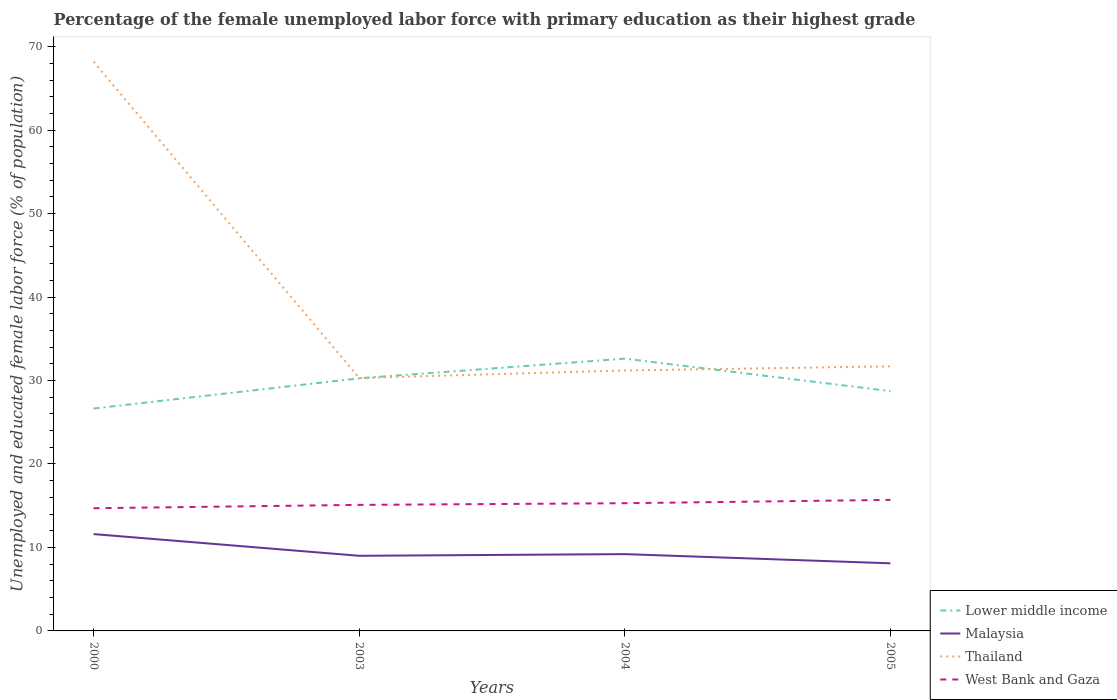Across all years, what is the maximum percentage of the unemployed female labor force with primary education in Lower middle income?
Provide a succinct answer. 26.65. In which year was the percentage of the unemployed female labor force with primary education in Lower middle income maximum?
Your answer should be compact. 2000. What is the total percentage of the unemployed female labor force with primary education in West Bank and Gaza in the graph?
Make the answer very short. -0.6. What is the difference between the highest and the second highest percentage of the unemployed female labor force with primary education in West Bank and Gaza?
Give a very brief answer. 1. What is the difference between the highest and the lowest percentage of the unemployed female labor force with primary education in West Bank and Gaza?
Your answer should be very brief. 2. Is the percentage of the unemployed female labor force with primary education in Malaysia strictly greater than the percentage of the unemployed female labor force with primary education in Thailand over the years?
Your response must be concise. Yes. How many years are there in the graph?
Offer a terse response. 4. Does the graph contain grids?
Offer a very short reply. No. Where does the legend appear in the graph?
Offer a very short reply. Bottom right. How are the legend labels stacked?
Provide a succinct answer. Vertical. What is the title of the graph?
Ensure brevity in your answer.  Percentage of the female unemployed labor force with primary education as their highest grade. What is the label or title of the X-axis?
Give a very brief answer. Years. What is the label or title of the Y-axis?
Ensure brevity in your answer.  Unemployed and educated female labor force (% of population). What is the Unemployed and educated female labor force (% of population) of Lower middle income in 2000?
Give a very brief answer. 26.65. What is the Unemployed and educated female labor force (% of population) in Malaysia in 2000?
Give a very brief answer. 11.6. What is the Unemployed and educated female labor force (% of population) in Thailand in 2000?
Offer a very short reply. 68.2. What is the Unemployed and educated female labor force (% of population) in West Bank and Gaza in 2000?
Ensure brevity in your answer.  14.7. What is the Unemployed and educated female labor force (% of population) of Lower middle income in 2003?
Your answer should be very brief. 30.26. What is the Unemployed and educated female labor force (% of population) in Malaysia in 2003?
Provide a succinct answer. 9. What is the Unemployed and educated female labor force (% of population) in Thailand in 2003?
Offer a terse response. 30.3. What is the Unemployed and educated female labor force (% of population) of West Bank and Gaza in 2003?
Offer a terse response. 15.1. What is the Unemployed and educated female labor force (% of population) of Lower middle income in 2004?
Provide a short and direct response. 32.62. What is the Unemployed and educated female labor force (% of population) in Malaysia in 2004?
Provide a short and direct response. 9.2. What is the Unemployed and educated female labor force (% of population) in Thailand in 2004?
Offer a very short reply. 31.2. What is the Unemployed and educated female labor force (% of population) of West Bank and Gaza in 2004?
Ensure brevity in your answer.  15.3. What is the Unemployed and educated female labor force (% of population) of Lower middle income in 2005?
Ensure brevity in your answer.  28.73. What is the Unemployed and educated female labor force (% of population) of Malaysia in 2005?
Your answer should be compact. 8.1. What is the Unemployed and educated female labor force (% of population) in Thailand in 2005?
Provide a succinct answer. 31.7. What is the Unemployed and educated female labor force (% of population) in West Bank and Gaza in 2005?
Your answer should be very brief. 15.7. Across all years, what is the maximum Unemployed and educated female labor force (% of population) of Lower middle income?
Provide a short and direct response. 32.62. Across all years, what is the maximum Unemployed and educated female labor force (% of population) of Malaysia?
Offer a terse response. 11.6. Across all years, what is the maximum Unemployed and educated female labor force (% of population) of Thailand?
Offer a terse response. 68.2. Across all years, what is the maximum Unemployed and educated female labor force (% of population) in West Bank and Gaza?
Ensure brevity in your answer.  15.7. Across all years, what is the minimum Unemployed and educated female labor force (% of population) in Lower middle income?
Your response must be concise. 26.65. Across all years, what is the minimum Unemployed and educated female labor force (% of population) of Malaysia?
Offer a very short reply. 8.1. Across all years, what is the minimum Unemployed and educated female labor force (% of population) of Thailand?
Your response must be concise. 30.3. Across all years, what is the minimum Unemployed and educated female labor force (% of population) of West Bank and Gaza?
Offer a very short reply. 14.7. What is the total Unemployed and educated female labor force (% of population) in Lower middle income in the graph?
Your response must be concise. 118.26. What is the total Unemployed and educated female labor force (% of population) of Malaysia in the graph?
Give a very brief answer. 37.9. What is the total Unemployed and educated female labor force (% of population) of Thailand in the graph?
Make the answer very short. 161.4. What is the total Unemployed and educated female labor force (% of population) of West Bank and Gaza in the graph?
Keep it short and to the point. 60.8. What is the difference between the Unemployed and educated female labor force (% of population) of Lower middle income in 2000 and that in 2003?
Your answer should be very brief. -3.62. What is the difference between the Unemployed and educated female labor force (% of population) in Thailand in 2000 and that in 2003?
Your answer should be very brief. 37.9. What is the difference between the Unemployed and educated female labor force (% of population) of West Bank and Gaza in 2000 and that in 2003?
Give a very brief answer. -0.4. What is the difference between the Unemployed and educated female labor force (% of population) of Lower middle income in 2000 and that in 2004?
Make the answer very short. -5.98. What is the difference between the Unemployed and educated female labor force (% of population) of Malaysia in 2000 and that in 2004?
Your answer should be very brief. 2.4. What is the difference between the Unemployed and educated female labor force (% of population) in Lower middle income in 2000 and that in 2005?
Your response must be concise. -2.09. What is the difference between the Unemployed and educated female labor force (% of population) in Malaysia in 2000 and that in 2005?
Your answer should be very brief. 3.5. What is the difference between the Unemployed and educated female labor force (% of population) of Thailand in 2000 and that in 2005?
Offer a terse response. 36.5. What is the difference between the Unemployed and educated female labor force (% of population) in West Bank and Gaza in 2000 and that in 2005?
Offer a very short reply. -1. What is the difference between the Unemployed and educated female labor force (% of population) in Lower middle income in 2003 and that in 2004?
Offer a very short reply. -2.36. What is the difference between the Unemployed and educated female labor force (% of population) of Malaysia in 2003 and that in 2004?
Your answer should be compact. -0.2. What is the difference between the Unemployed and educated female labor force (% of population) of Lower middle income in 2003 and that in 2005?
Your answer should be compact. 1.53. What is the difference between the Unemployed and educated female labor force (% of population) in Thailand in 2003 and that in 2005?
Your answer should be compact. -1.4. What is the difference between the Unemployed and educated female labor force (% of population) in Lower middle income in 2004 and that in 2005?
Provide a short and direct response. 3.89. What is the difference between the Unemployed and educated female labor force (% of population) of West Bank and Gaza in 2004 and that in 2005?
Give a very brief answer. -0.4. What is the difference between the Unemployed and educated female labor force (% of population) of Lower middle income in 2000 and the Unemployed and educated female labor force (% of population) of Malaysia in 2003?
Keep it short and to the point. 17.65. What is the difference between the Unemployed and educated female labor force (% of population) in Lower middle income in 2000 and the Unemployed and educated female labor force (% of population) in Thailand in 2003?
Ensure brevity in your answer.  -3.65. What is the difference between the Unemployed and educated female labor force (% of population) of Lower middle income in 2000 and the Unemployed and educated female labor force (% of population) of West Bank and Gaza in 2003?
Provide a short and direct response. 11.55. What is the difference between the Unemployed and educated female labor force (% of population) of Malaysia in 2000 and the Unemployed and educated female labor force (% of population) of Thailand in 2003?
Your answer should be very brief. -18.7. What is the difference between the Unemployed and educated female labor force (% of population) of Thailand in 2000 and the Unemployed and educated female labor force (% of population) of West Bank and Gaza in 2003?
Make the answer very short. 53.1. What is the difference between the Unemployed and educated female labor force (% of population) in Lower middle income in 2000 and the Unemployed and educated female labor force (% of population) in Malaysia in 2004?
Offer a terse response. 17.45. What is the difference between the Unemployed and educated female labor force (% of population) in Lower middle income in 2000 and the Unemployed and educated female labor force (% of population) in Thailand in 2004?
Ensure brevity in your answer.  -4.55. What is the difference between the Unemployed and educated female labor force (% of population) in Lower middle income in 2000 and the Unemployed and educated female labor force (% of population) in West Bank and Gaza in 2004?
Ensure brevity in your answer.  11.35. What is the difference between the Unemployed and educated female labor force (% of population) of Malaysia in 2000 and the Unemployed and educated female labor force (% of population) of Thailand in 2004?
Offer a very short reply. -19.6. What is the difference between the Unemployed and educated female labor force (% of population) of Thailand in 2000 and the Unemployed and educated female labor force (% of population) of West Bank and Gaza in 2004?
Give a very brief answer. 52.9. What is the difference between the Unemployed and educated female labor force (% of population) of Lower middle income in 2000 and the Unemployed and educated female labor force (% of population) of Malaysia in 2005?
Your answer should be compact. 18.55. What is the difference between the Unemployed and educated female labor force (% of population) of Lower middle income in 2000 and the Unemployed and educated female labor force (% of population) of Thailand in 2005?
Give a very brief answer. -5.05. What is the difference between the Unemployed and educated female labor force (% of population) in Lower middle income in 2000 and the Unemployed and educated female labor force (% of population) in West Bank and Gaza in 2005?
Ensure brevity in your answer.  10.95. What is the difference between the Unemployed and educated female labor force (% of population) in Malaysia in 2000 and the Unemployed and educated female labor force (% of population) in Thailand in 2005?
Offer a terse response. -20.1. What is the difference between the Unemployed and educated female labor force (% of population) in Malaysia in 2000 and the Unemployed and educated female labor force (% of population) in West Bank and Gaza in 2005?
Give a very brief answer. -4.1. What is the difference between the Unemployed and educated female labor force (% of population) of Thailand in 2000 and the Unemployed and educated female labor force (% of population) of West Bank and Gaza in 2005?
Provide a succinct answer. 52.5. What is the difference between the Unemployed and educated female labor force (% of population) in Lower middle income in 2003 and the Unemployed and educated female labor force (% of population) in Malaysia in 2004?
Your response must be concise. 21.06. What is the difference between the Unemployed and educated female labor force (% of population) in Lower middle income in 2003 and the Unemployed and educated female labor force (% of population) in Thailand in 2004?
Keep it short and to the point. -0.94. What is the difference between the Unemployed and educated female labor force (% of population) in Lower middle income in 2003 and the Unemployed and educated female labor force (% of population) in West Bank and Gaza in 2004?
Offer a terse response. 14.96. What is the difference between the Unemployed and educated female labor force (% of population) of Malaysia in 2003 and the Unemployed and educated female labor force (% of population) of Thailand in 2004?
Provide a short and direct response. -22.2. What is the difference between the Unemployed and educated female labor force (% of population) of Lower middle income in 2003 and the Unemployed and educated female labor force (% of population) of Malaysia in 2005?
Offer a terse response. 22.16. What is the difference between the Unemployed and educated female labor force (% of population) in Lower middle income in 2003 and the Unemployed and educated female labor force (% of population) in Thailand in 2005?
Ensure brevity in your answer.  -1.44. What is the difference between the Unemployed and educated female labor force (% of population) of Lower middle income in 2003 and the Unemployed and educated female labor force (% of population) of West Bank and Gaza in 2005?
Provide a short and direct response. 14.56. What is the difference between the Unemployed and educated female labor force (% of population) of Malaysia in 2003 and the Unemployed and educated female labor force (% of population) of Thailand in 2005?
Offer a terse response. -22.7. What is the difference between the Unemployed and educated female labor force (% of population) of Thailand in 2003 and the Unemployed and educated female labor force (% of population) of West Bank and Gaza in 2005?
Ensure brevity in your answer.  14.6. What is the difference between the Unemployed and educated female labor force (% of population) in Lower middle income in 2004 and the Unemployed and educated female labor force (% of population) in Malaysia in 2005?
Keep it short and to the point. 24.52. What is the difference between the Unemployed and educated female labor force (% of population) of Lower middle income in 2004 and the Unemployed and educated female labor force (% of population) of Thailand in 2005?
Your response must be concise. 0.92. What is the difference between the Unemployed and educated female labor force (% of population) of Lower middle income in 2004 and the Unemployed and educated female labor force (% of population) of West Bank and Gaza in 2005?
Keep it short and to the point. 16.92. What is the difference between the Unemployed and educated female labor force (% of population) of Malaysia in 2004 and the Unemployed and educated female labor force (% of population) of Thailand in 2005?
Offer a very short reply. -22.5. What is the difference between the Unemployed and educated female labor force (% of population) in Malaysia in 2004 and the Unemployed and educated female labor force (% of population) in West Bank and Gaza in 2005?
Your answer should be compact. -6.5. What is the difference between the Unemployed and educated female labor force (% of population) of Thailand in 2004 and the Unemployed and educated female labor force (% of population) of West Bank and Gaza in 2005?
Give a very brief answer. 15.5. What is the average Unemployed and educated female labor force (% of population) in Lower middle income per year?
Give a very brief answer. 29.57. What is the average Unemployed and educated female labor force (% of population) in Malaysia per year?
Ensure brevity in your answer.  9.47. What is the average Unemployed and educated female labor force (% of population) in Thailand per year?
Offer a very short reply. 40.35. What is the average Unemployed and educated female labor force (% of population) of West Bank and Gaza per year?
Provide a short and direct response. 15.2. In the year 2000, what is the difference between the Unemployed and educated female labor force (% of population) of Lower middle income and Unemployed and educated female labor force (% of population) of Malaysia?
Your answer should be very brief. 15.05. In the year 2000, what is the difference between the Unemployed and educated female labor force (% of population) in Lower middle income and Unemployed and educated female labor force (% of population) in Thailand?
Your answer should be compact. -41.55. In the year 2000, what is the difference between the Unemployed and educated female labor force (% of population) in Lower middle income and Unemployed and educated female labor force (% of population) in West Bank and Gaza?
Your answer should be very brief. 11.95. In the year 2000, what is the difference between the Unemployed and educated female labor force (% of population) in Malaysia and Unemployed and educated female labor force (% of population) in Thailand?
Give a very brief answer. -56.6. In the year 2000, what is the difference between the Unemployed and educated female labor force (% of population) of Malaysia and Unemployed and educated female labor force (% of population) of West Bank and Gaza?
Your response must be concise. -3.1. In the year 2000, what is the difference between the Unemployed and educated female labor force (% of population) of Thailand and Unemployed and educated female labor force (% of population) of West Bank and Gaza?
Your answer should be very brief. 53.5. In the year 2003, what is the difference between the Unemployed and educated female labor force (% of population) in Lower middle income and Unemployed and educated female labor force (% of population) in Malaysia?
Keep it short and to the point. 21.26. In the year 2003, what is the difference between the Unemployed and educated female labor force (% of population) in Lower middle income and Unemployed and educated female labor force (% of population) in Thailand?
Your answer should be very brief. -0.04. In the year 2003, what is the difference between the Unemployed and educated female labor force (% of population) of Lower middle income and Unemployed and educated female labor force (% of population) of West Bank and Gaza?
Your answer should be compact. 15.16. In the year 2003, what is the difference between the Unemployed and educated female labor force (% of population) of Malaysia and Unemployed and educated female labor force (% of population) of Thailand?
Ensure brevity in your answer.  -21.3. In the year 2003, what is the difference between the Unemployed and educated female labor force (% of population) of Thailand and Unemployed and educated female labor force (% of population) of West Bank and Gaza?
Offer a very short reply. 15.2. In the year 2004, what is the difference between the Unemployed and educated female labor force (% of population) of Lower middle income and Unemployed and educated female labor force (% of population) of Malaysia?
Make the answer very short. 23.42. In the year 2004, what is the difference between the Unemployed and educated female labor force (% of population) in Lower middle income and Unemployed and educated female labor force (% of population) in Thailand?
Provide a short and direct response. 1.42. In the year 2004, what is the difference between the Unemployed and educated female labor force (% of population) in Lower middle income and Unemployed and educated female labor force (% of population) in West Bank and Gaza?
Your answer should be compact. 17.32. In the year 2004, what is the difference between the Unemployed and educated female labor force (% of population) of Malaysia and Unemployed and educated female labor force (% of population) of Thailand?
Provide a short and direct response. -22. In the year 2005, what is the difference between the Unemployed and educated female labor force (% of population) in Lower middle income and Unemployed and educated female labor force (% of population) in Malaysia?
Your answer should be compact. 20.63. In the year 2005, what is the difference between the Unemployed and educated female labor force (% of population) of Lower middle income and Unemployed and educated female labor force (% of population) of Thailand?
Offer a terse response. -2.97. In the year 2005, what is the difference between the Unemployed and educated female labor force (% of population) in Lower middle income and Unemployed and educated female labor force (% of population) in West Bank and Gaza?
Make the answer very short. 13.03. In the year 2005, what is the difference between the Unemployed and educated female labor force (% of population) of Malaysia and Unemployed and educated female labor force (% of population) of Thailand?
Offer a terse response. -23.6. In the year 2005, what is the difference between the Unemployed and educated female labor force (% of population) of Thailand and Unemployed and educated female labor force (% of population) of West Bank and Gaza?
Make the answer very short. 16. What is the ratio of the Unemployed and educated female labor force (% of population) in Lower middle income in 2000 to that in 2003?
Your response must be concise. 0.88. What is the ratio of the Unemployed and educated female labor force (% of population) of Malaysia in 2000 to that in 2003?
Make the answer very short. 1.29. What is the ratio of the Unemployed and educated female labor force (% of population) of Thailand in 2000 to that in 2003?
Offer a terse response. 2.25. What is the ratio of the Unemployed and educated female labor force (% of population) of West Bank and Gaza in 2000 to that in 2003?
Provide a short and direct response. 0.97. What is the ratio of the Unemployed and educated female labor force (% of population) of Lower middle income in 2000 to that in 2004?
Your response must be concise. 0.82. What is the ratio of the Unemployed and educated female labor force (% of population) of Malaysia in 2000 to that in 2004?
Offer a very short reply. 1.26. What is the ratio of the Unemployed and educated female labor force (% of population) of Thailand in 2000 to that in 2004?
Provide a short and direct response. 2.19. What is the ratio of the Unemployed and educated female labor force (% of population) of West Bank and Gaza in 2000 to that in 2004?
Provide a short and direct response. 0.96. What is the ratio of the Unemployed and educated female labor force (% of population) of Lower middle income in 2000 to that in 2005?
Ensure brevity in your answer.  0.93. What is the ratio of the Unemployed and educated female labor force (% of population) of Malaysia in 2000 to that in 2005?
Provide a short and direct response. 1.43. What is the ratio of the Unemployed and educated female labor force (% of population) of Thailand in 2000 to that in 2005?
Your answer should be very brief. 2.15. What is the ratio of the Unemployed and educated female labor force (% of population) in West Bank and Gaza in 2000 to that in 2005?
Offer a terse response. 0.94. What is the ratio of the Unemployed and educated female labor force (% of population) in Lower middle income in 2003 to that in 2004?
Your answer should be very brief. 0.93. What is the ratio of the Unemployed and educated female labor force (% of population) of Malaysia in 2003 to that in 2004?
Keep it short and to the point. 0.98. What is the ratio of the Unemployed and educated female labor force (% of population) in Thailand in 2003 to that in 2004?
Offer a terse response. 0.97. What is the ratio of the Unemployed and educated female labor force (% of population) in West Bank and Gaza in 2003 to that in 2004?
Ensure brevity in your answer.  0.99. What is the ratio of the Unemployed and educated female labor force (% of population) in Lower middle income in 2003 to that in 2005?
Your answer should be very brief. 1.05. What is the ratio of the Unemployed and educated female labor force (% of population) of Malaysia in 2003 to that in 2005?
Give a very brief answer. 1.11. What is the ratio of the Unemployed and educated female labor force (% of population) in Thailand in 2003 to that in 2005?
Your response must be concise. 0.96. What is the ratio of the Unemployed and educated female labor force (% of population) in West Bank and Gaza in 2003 to that in 2005?
Provide a short and direct response. 0.96. What is the ratio of the Unemployed and educated female labor force (% of population) of Lower middle income in 2004 to that in 2005?
Keep it short and to the point. 1.14. What is the ratio of the Unemployed and educated female labor force (% of population) in Malaysia in 2004 to that in 2005?
Your response must be concise. 1.14. What is the ratio of the Unemployed and educated female labor force (% of population) of Thailand in 2004 to that in 2005?
Make the answer very short. 0.98. What is the ratio of the Unemployed and educated female labor force (% of population) of West Bank and Gaza in 2004 to that in 2005?
Ensure brevity in your answer.  0.97. What is the difference between the highest and the second highest Unemployed and educated female labor force (% of population) of Lower middle income?
Offer a very short reply. 2.36. What is the difference between the highest and the second highest Unemployed and educated female labor force (% of population) of Malaysia?
Give a very brief answer. 2.4. What is the difference between the highest and the second highest Unemployed and educated female labor force (% of population) in Thailand?
Ensure brevity in your answer.  36.5. What is the difference between the highest and the lowest Unemployed and educated female labor force (% of population) of Lower middle income?
Ensure brevity in your answer.  5.98. What is the difference between the highest and the lowest Unemployed and educated female labor force (% of population) in Malaysia?
Offer a very short reply. 3.5. What is the difference between the highest and the lowest Unemployed and educated female labor force (% of population) of Thailand?
Your response must be concise. 37.9. 